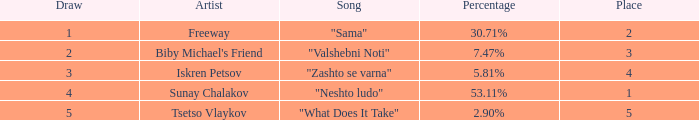Can you parse all the data within this table? {'header': ['Draw', 'Artist', 'Song', 'Percentage', 'Place'], 'rows': [['1', 'Freeway', '"Sama"', '30.71%', '2'], ['2', "Biby Michael's Friend", '"Valshebni Noti"', '7.47%', '3'], ['3', 'Iskren Petsov', '"Zashto se varna"', '5.81%', '4'], ['4', 'Sunay Chalakov', '"Neshto ludo"', '53.11%', '1'], ['5', 'Tsetso Vlaykov', '"What Does It Take"', '2.90%', '5']]} What is the minimum draw when the position is above 4? 5.0. 